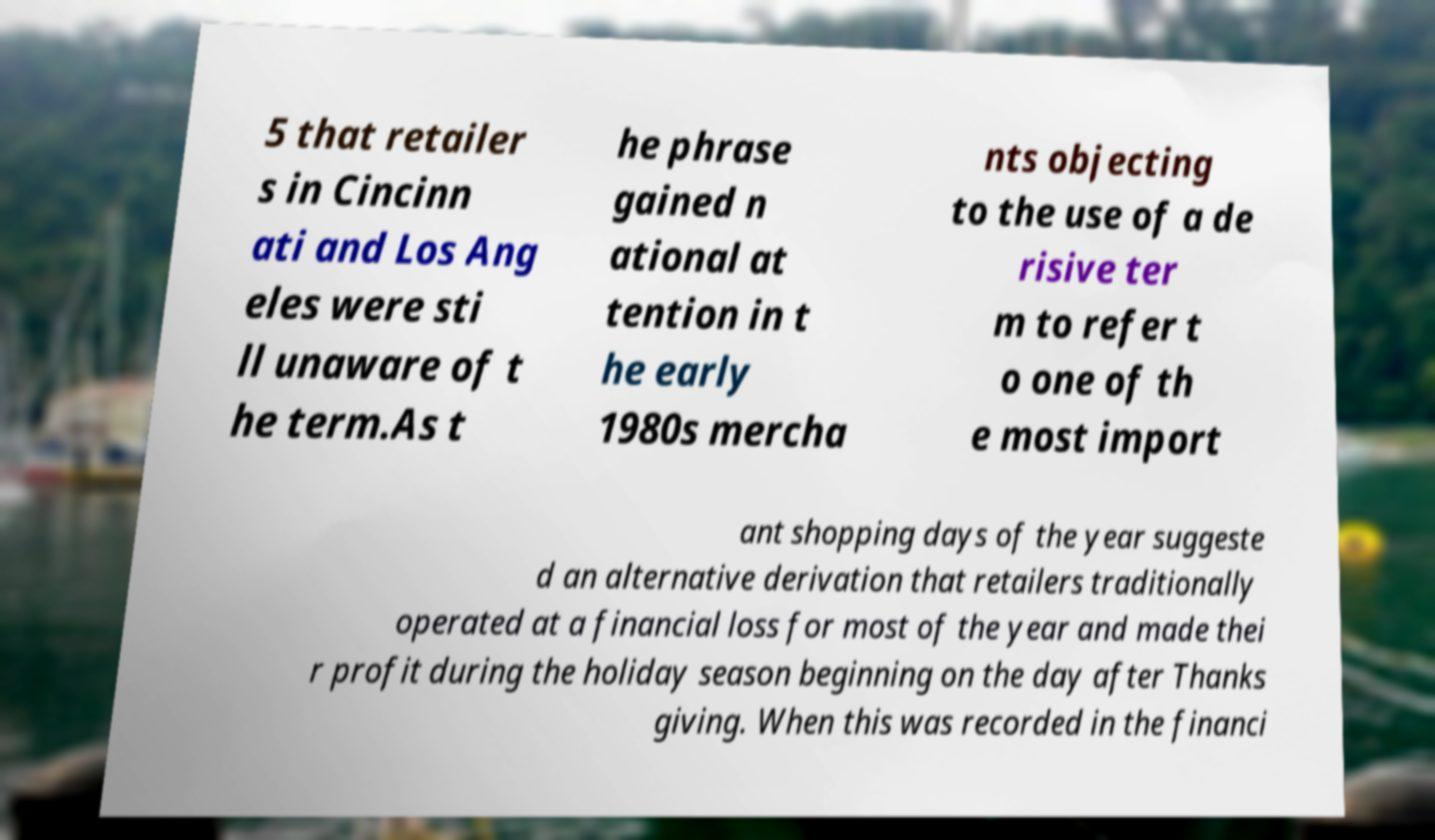Could you extract and type out the text from this image? 5 that retailer s in Cincinn ati and Los Ang eles were sti ll unaware of t he term.As t he phrase gained n ational at tention in t he early 1980s mercha nts objecting to the use of a de risive ter m to refer t o one of th e most import ant shopping days of the year suggeste d an alternative derivation that retailers traditionally operated at a financial loss for most of the year and made thei r profit during the holiday season beginning on the day after Thanks giving. When this was recorded in the financi 